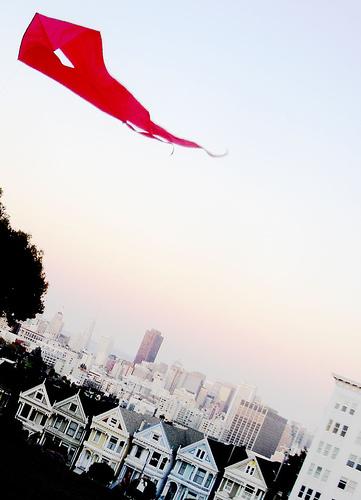Is this a bird?
Be succinct. No. What color is the kite?
Answer briefly. Red. What color is the sky?
Answer briefly. Blue. 